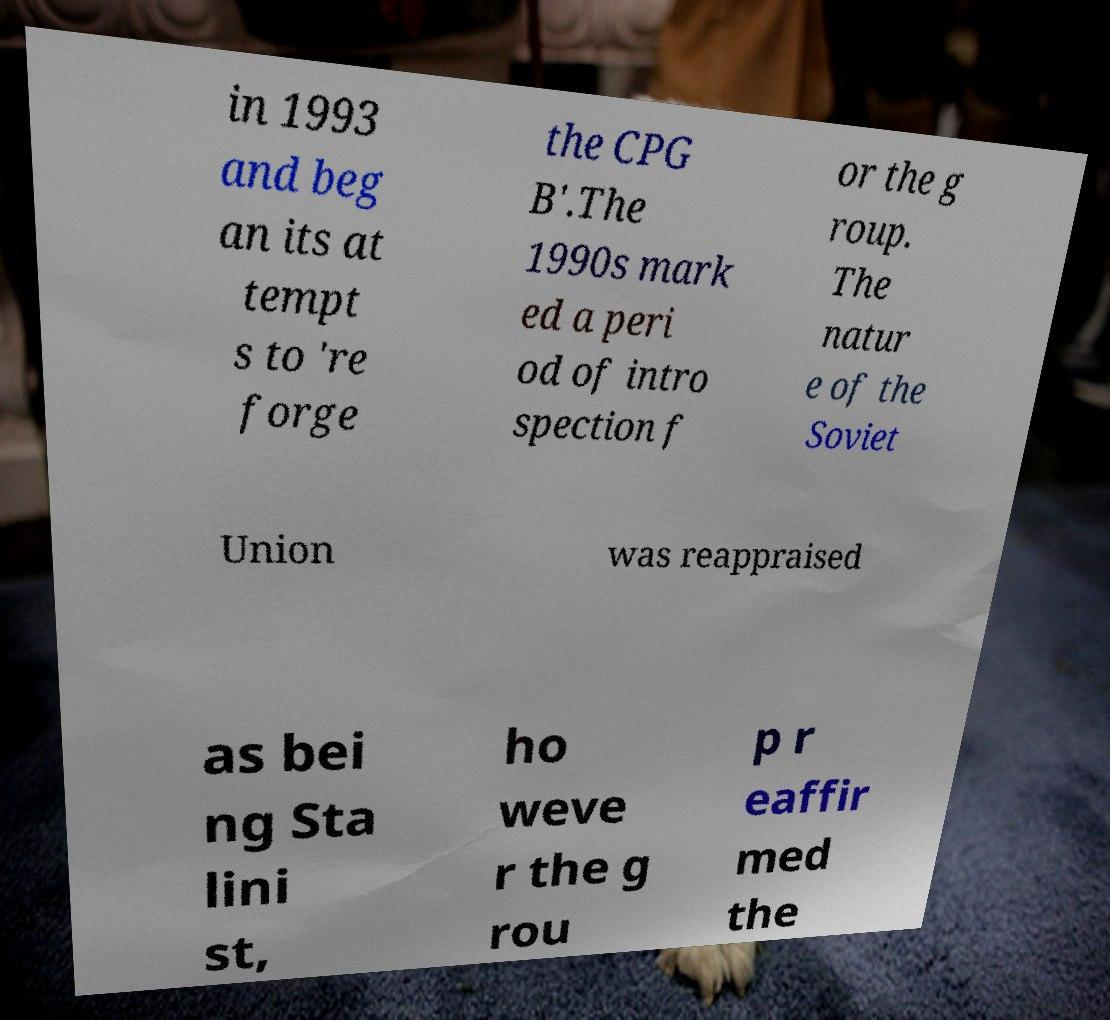Could you extract and type out the text from this image? in 1993 and beg an its at tempt s to 're forge the CPG B'.The 1990s mark ed a peri od of intro spection f or the g roup. The natur e of the Soviet Union was reappraised as bei ng Sta lini st, ho weve r the g rou p r eaffir med the 